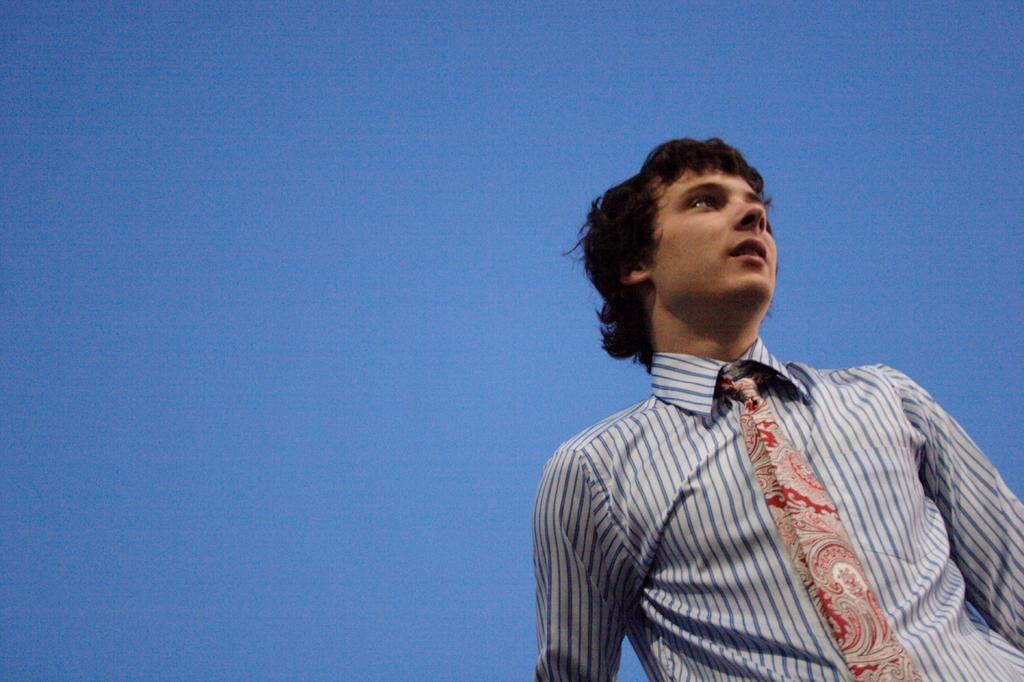What is the person doing in the image? The person is standing on the right side of the image. What can be seen on the person's outfit? The person is wearing a tie and a blue and white color shirt. What is visible in the background of the image? There is a sky visible in the background of the image. What type of clouds can be seen in the image? There are no clouds visible in the image; only the sky is mentioned in the background. 